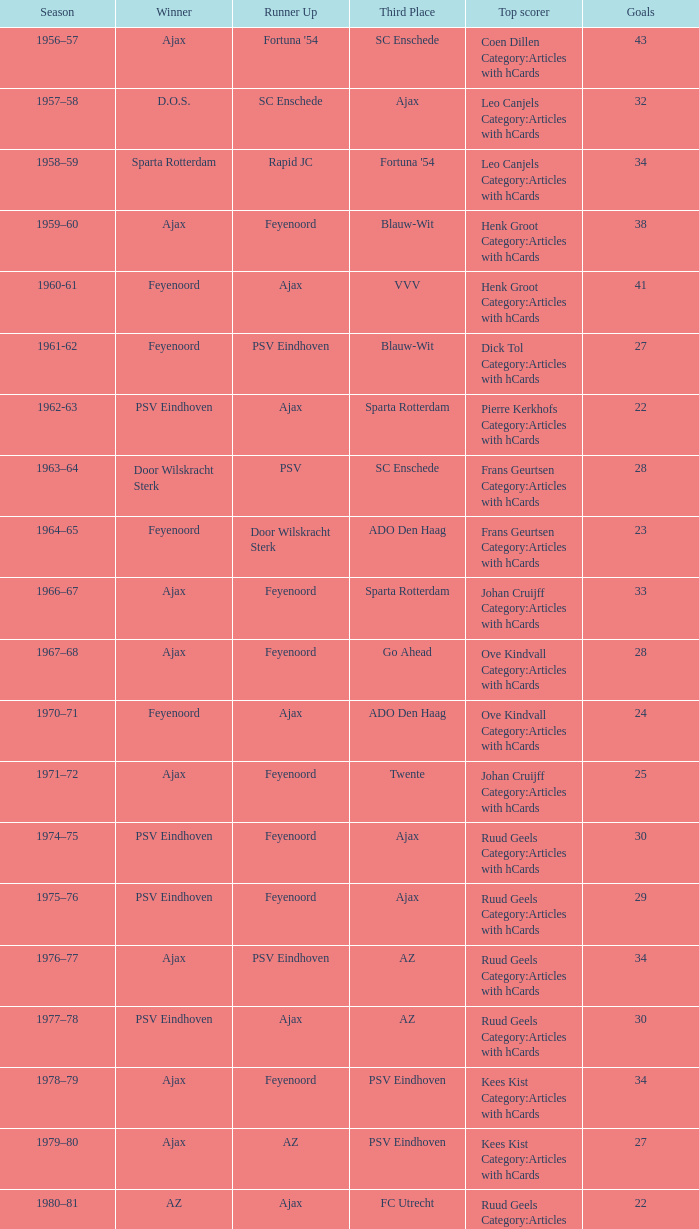In which seasons did twente finish third and ajax claim the victory? 1971–72, 1989-90. 